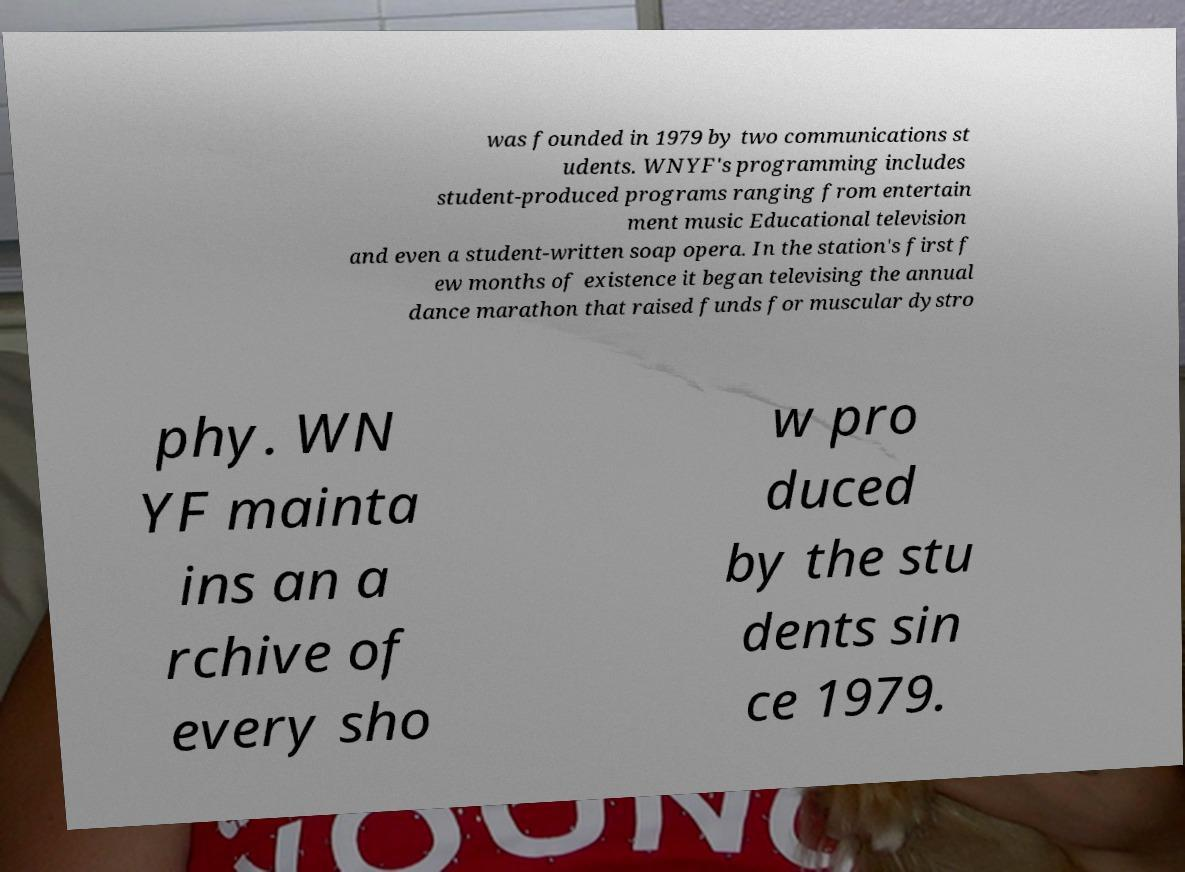I need the written content from this picture converted into text. Can you do that? was founded in 1979 by two communications st udents. WNYF's programming includes student-produced programs ranging from entertain ment music Educational television and even a student-written soap opera. In the station's first f ew months of existence it began televising the annual dance marathon that raised funds for muscular dystro phy. WN YF mainta ins an a rchive of every sho w pro duced by the stu dents sin ce 1979. 